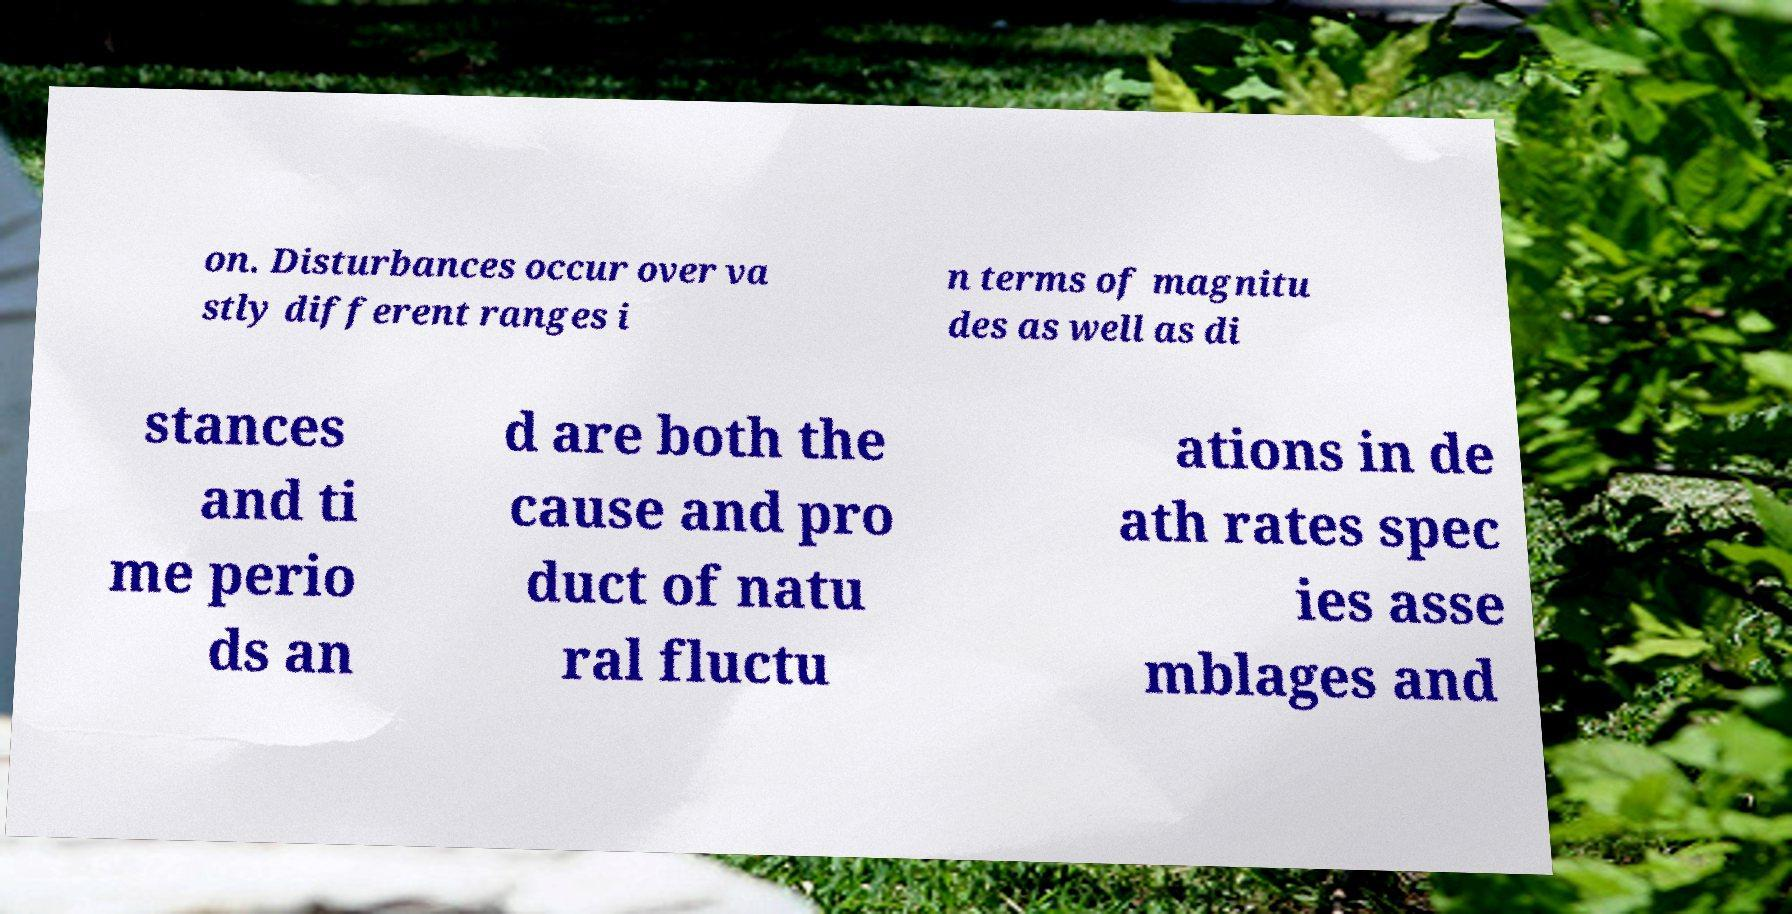What messages or text are displayed in this image? I need them in a readable, typed format. on. Disturbances occur over va stly different ranges i n terms of magnitu des as well as di stances and ti me perio ds an d are both the cause and pro duct of natu ral fluctu ations in de ath rates spec ies asse mblages and 